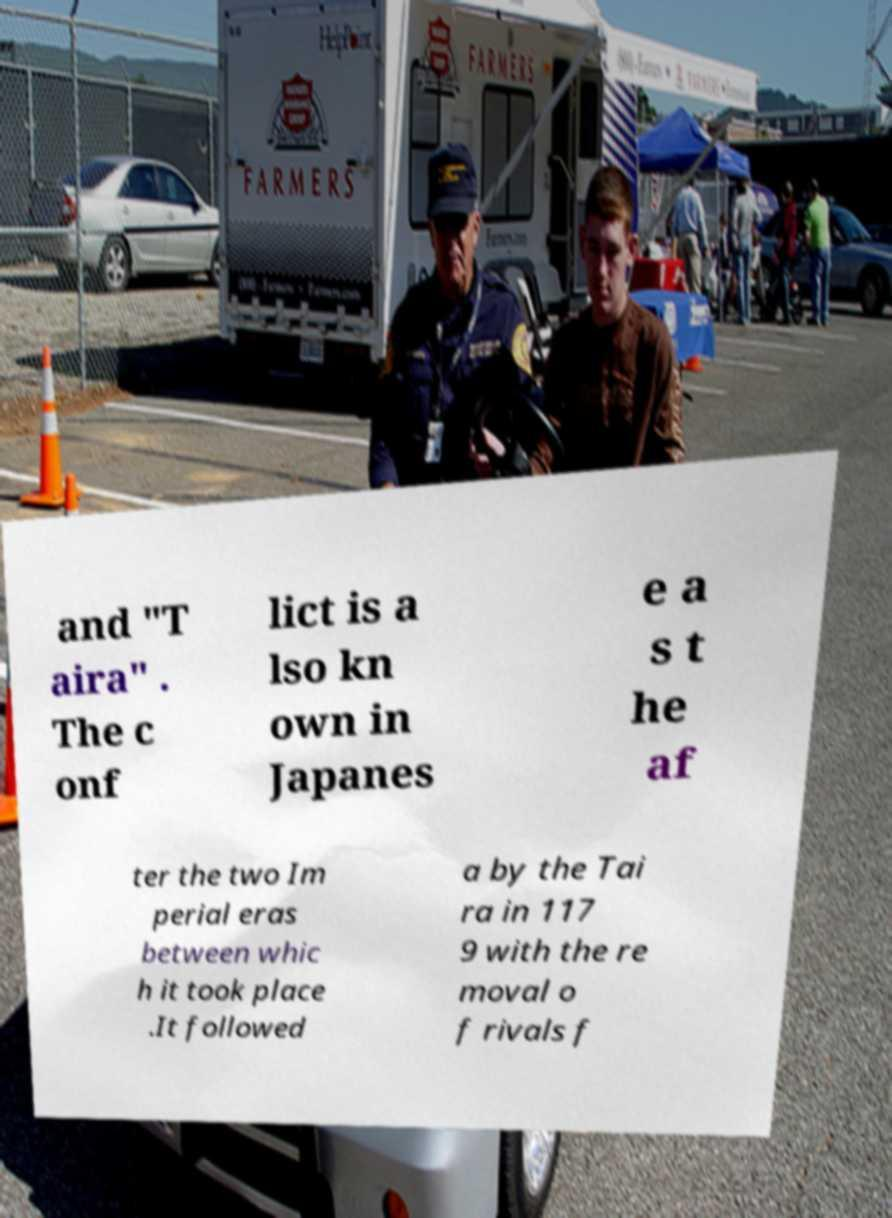There's text embedded in this image that I need extracted. Can you transcribe it verbatim? and "T aira" . The c onf lict is a lso kn own in Japanes e a s t he af ter the two Im perial eras between whic h it took place .It followed a by the Tai ra in 117 9 with the re moval o f rivals f 